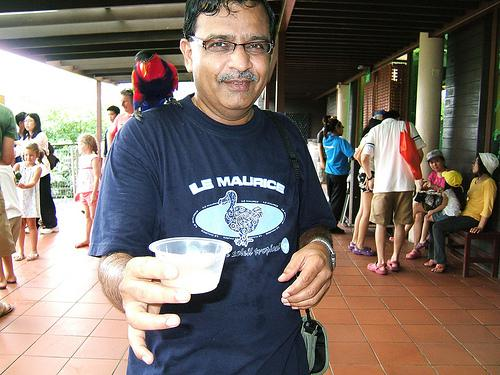Question: what does the man's shirt say?
Choices:
A. C'est Bon.
B. C'est La Vie.
C. Le Maurice.
D. Bonjour.
Answer with the letter. Answer: C Question: what does the man have on his eyes?
Choices:
A. A patch.
B. Glasses.
C. Sunglasses.
D. Nothing.
Answer with the letter. Answer: B Question: what kind of animal is resting on the man's shoulder?
Choices:
A. A lizard.
B. A monkey.
C. A ferret.
D. Bird.
Answer with the letter. Answer: D 